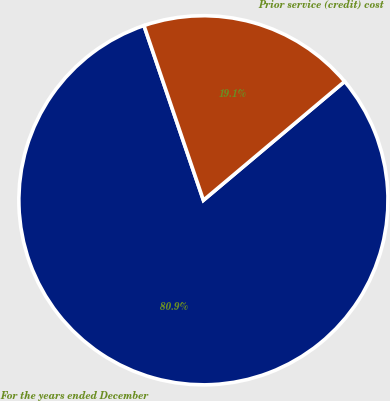Convert chart. <chart><loc_0><loc_0><loc_500><loc_500><pie_chart><fcel>For the years ended December<fcel>Prior service (credit) cost<nl><fcel>80.91%<fcel>19.09%<nl></chart> 